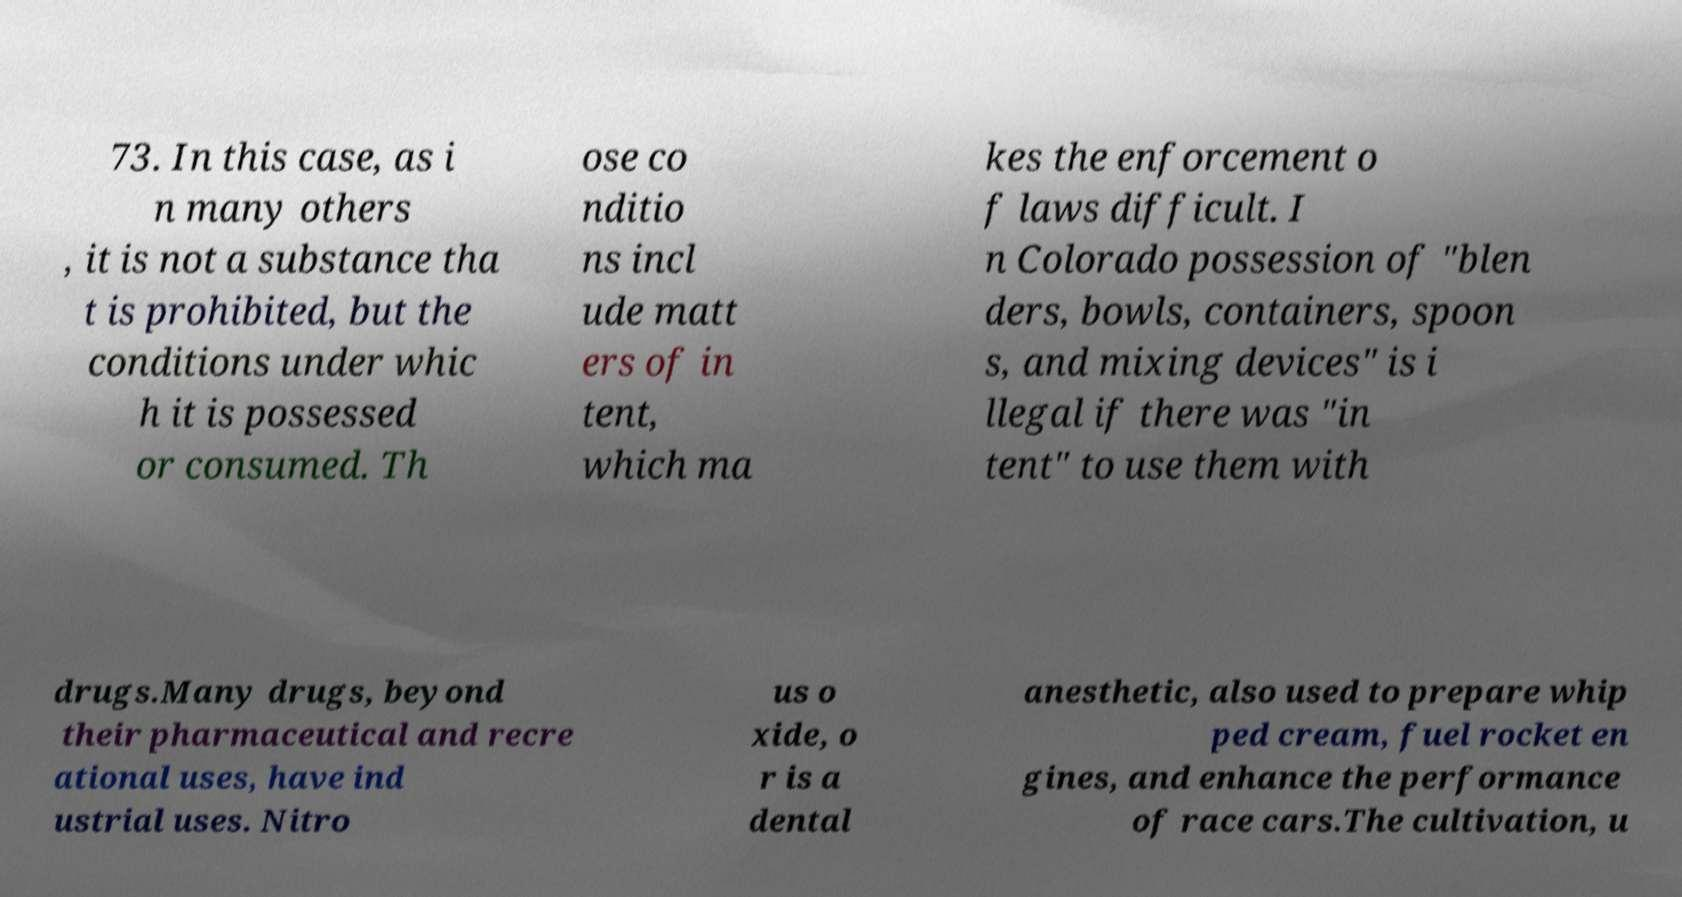Please identify and transcribe the text found in this image. 73. In this case, as i n many others , it is not a substance tha t is prohibited, but the conditions under whic h it is possessed or consumed. Th ose co nditio ns incl ude matt ers of in tent, which ma kes the enforcement o f laws difficult. I n Colorado possession of "blen ders, bowls, containers, spoon s, and mixing devices" is i llegal if there was "in tent" to use them with drugs.Many drugs, beyond their pharmaceutical and recre ational uses, have ind ustrial uses. Nitro us o xide, o r is a dental anesthetic, also used to prepare whip ped cream, fuel rocket en gines, and enhance the performance of race cars.The cultivation, u 